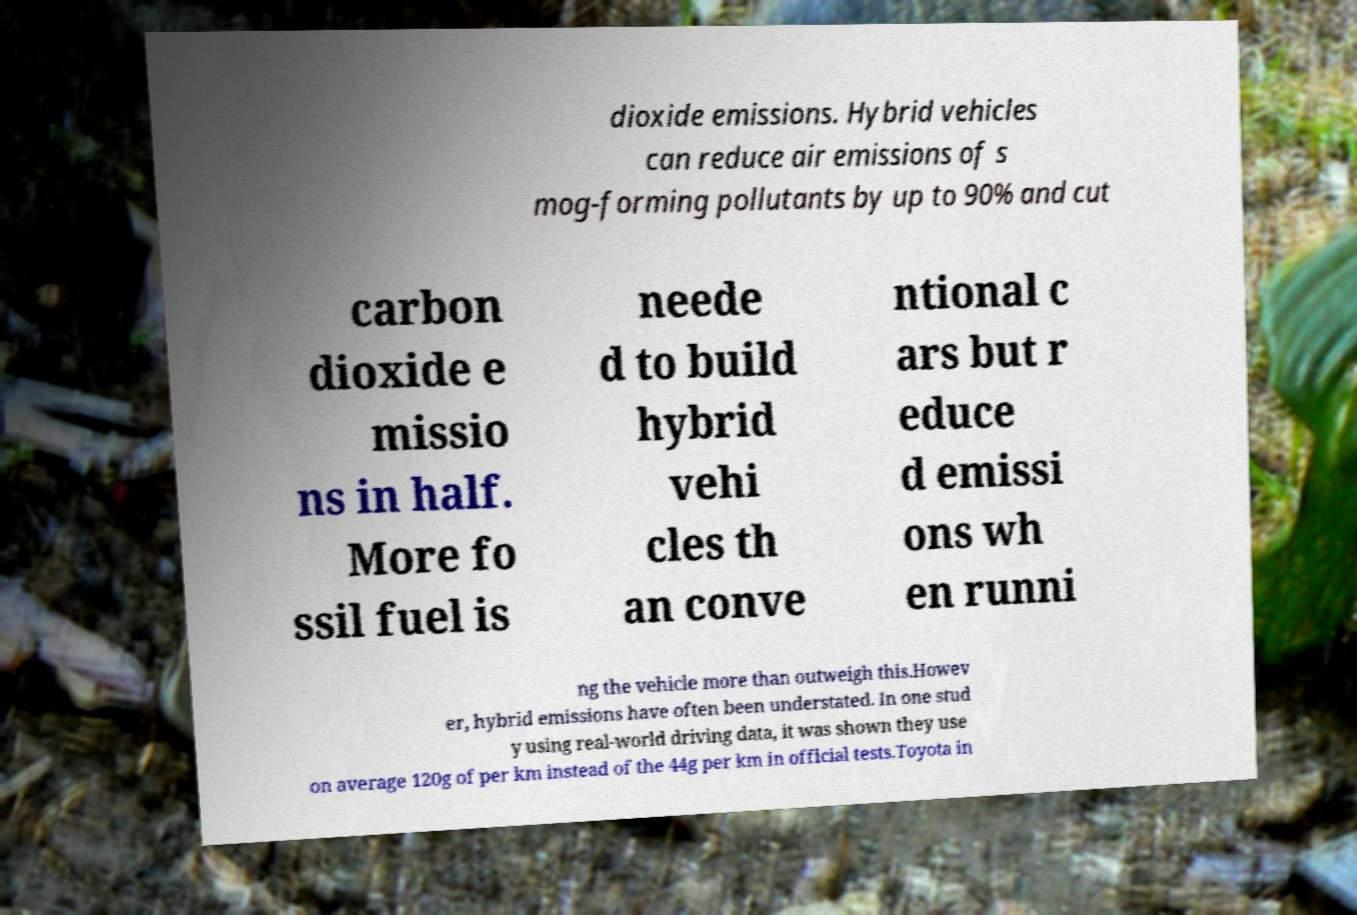I need the written content from this picture converted into text. Can you do that? dioxide emissions. Hybrid vehicles can reduce air emissions of s mog-forming pollutants by up to 90% and cut carbon dioxide e missio ns in half. More fo ssil fuel is neede d to build hybrid vehi cles th an conve ntional c ars but r educe d emissi ons wh en runni ng the vehicle more than outweigh this.Howev er, hybrid emissions have often been understated. In one stud y using real-world driving data, it was shown they use on average 120g of per km instead of the 44g per km in official tests.Toyota in 